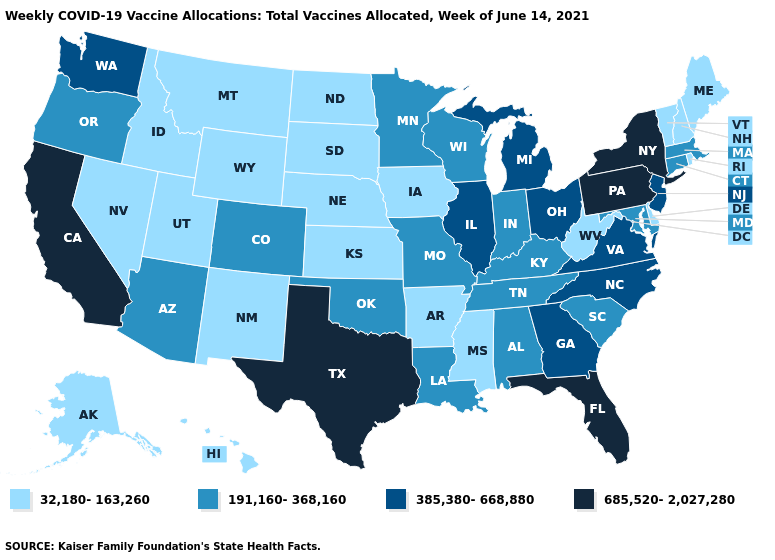What is the lowest value in states that border Iowa?
Concise answer only. 32,180-163,260. What is the value of Arkansas?
Answer briefly. 32,180-163,260. What is the value of Florida?
Be succinct. 685,520-2,027,280. Among the states that border Connecticut , does New York have the highest value?
Keep it brief. Yes. Which states have the highest value in the USA?
Keep it brief. California, Florida, New York, Pennsylvania, Texas. Name the states that have a value in the range 685,520-2,027,280?
Short answer required. California, Florida, New York, Pennsylvania, Texas. Name the states that have a value in the range 191,160-368,160?
Write a very short answer. Alabama, Arizona, Colorado, Connecticut, Indiana, Kentucky, Louisiana, Maryland, Massachusetts, Minnesota, Missouri, Oklahoma, Oregon, South Carolina, Tennessee, Wisconsin. Name the states that have a value in the range 385,380-668,880?
Give a very brief answer. Georgia, Illinois, Michigan, New Jersey, North Carolina, Ohio, Virginia, Washington. Does Illinois have the highest value in the MidWest?
Quick response, please. Yes. What is the value of South Carolina?
Short answer required. 191,160-368,160. What is the highest value in the USA?
Concise answer only. 685,520-2,027,280. Does California have the highest value in the USA?
Write a very short answer. Yes. What is the highest value in the USA?
Give a very brief answer. 685,520-2,027,280. 